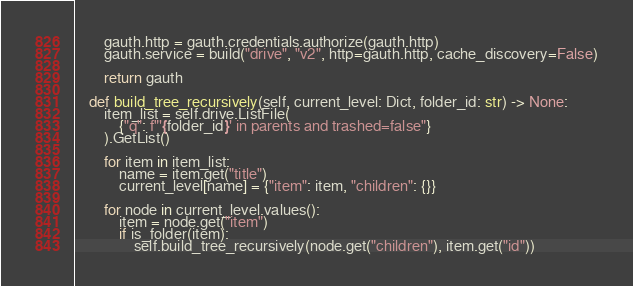Convert code to text. <code><loc_0><loc_0><loc_500><loc_500><_Python_>        gauth.http = gauth.credentials.authorize(gauth.http)
        gauth.service = build("drive", "v2", http=gauth.http, cache_discovery=False)

        return gauth

    def build_tree_recursively(self, current_level: Dict, folder_id: str) -> None:
        item_list = self.drive.ListFile(
            {"q": f"'{folder_id}' in parents and trashed=false"}
        ).GetList()

        for item in item_list:
            name = item.get("title")
            current_level[name] = {"item": item, "children": {}}

        for node in current_level.values():
            item = node.get("item")
            if is_folder(item):
                self.build_tree_recursively(node.get("children"), item.get("id"))
</code> 